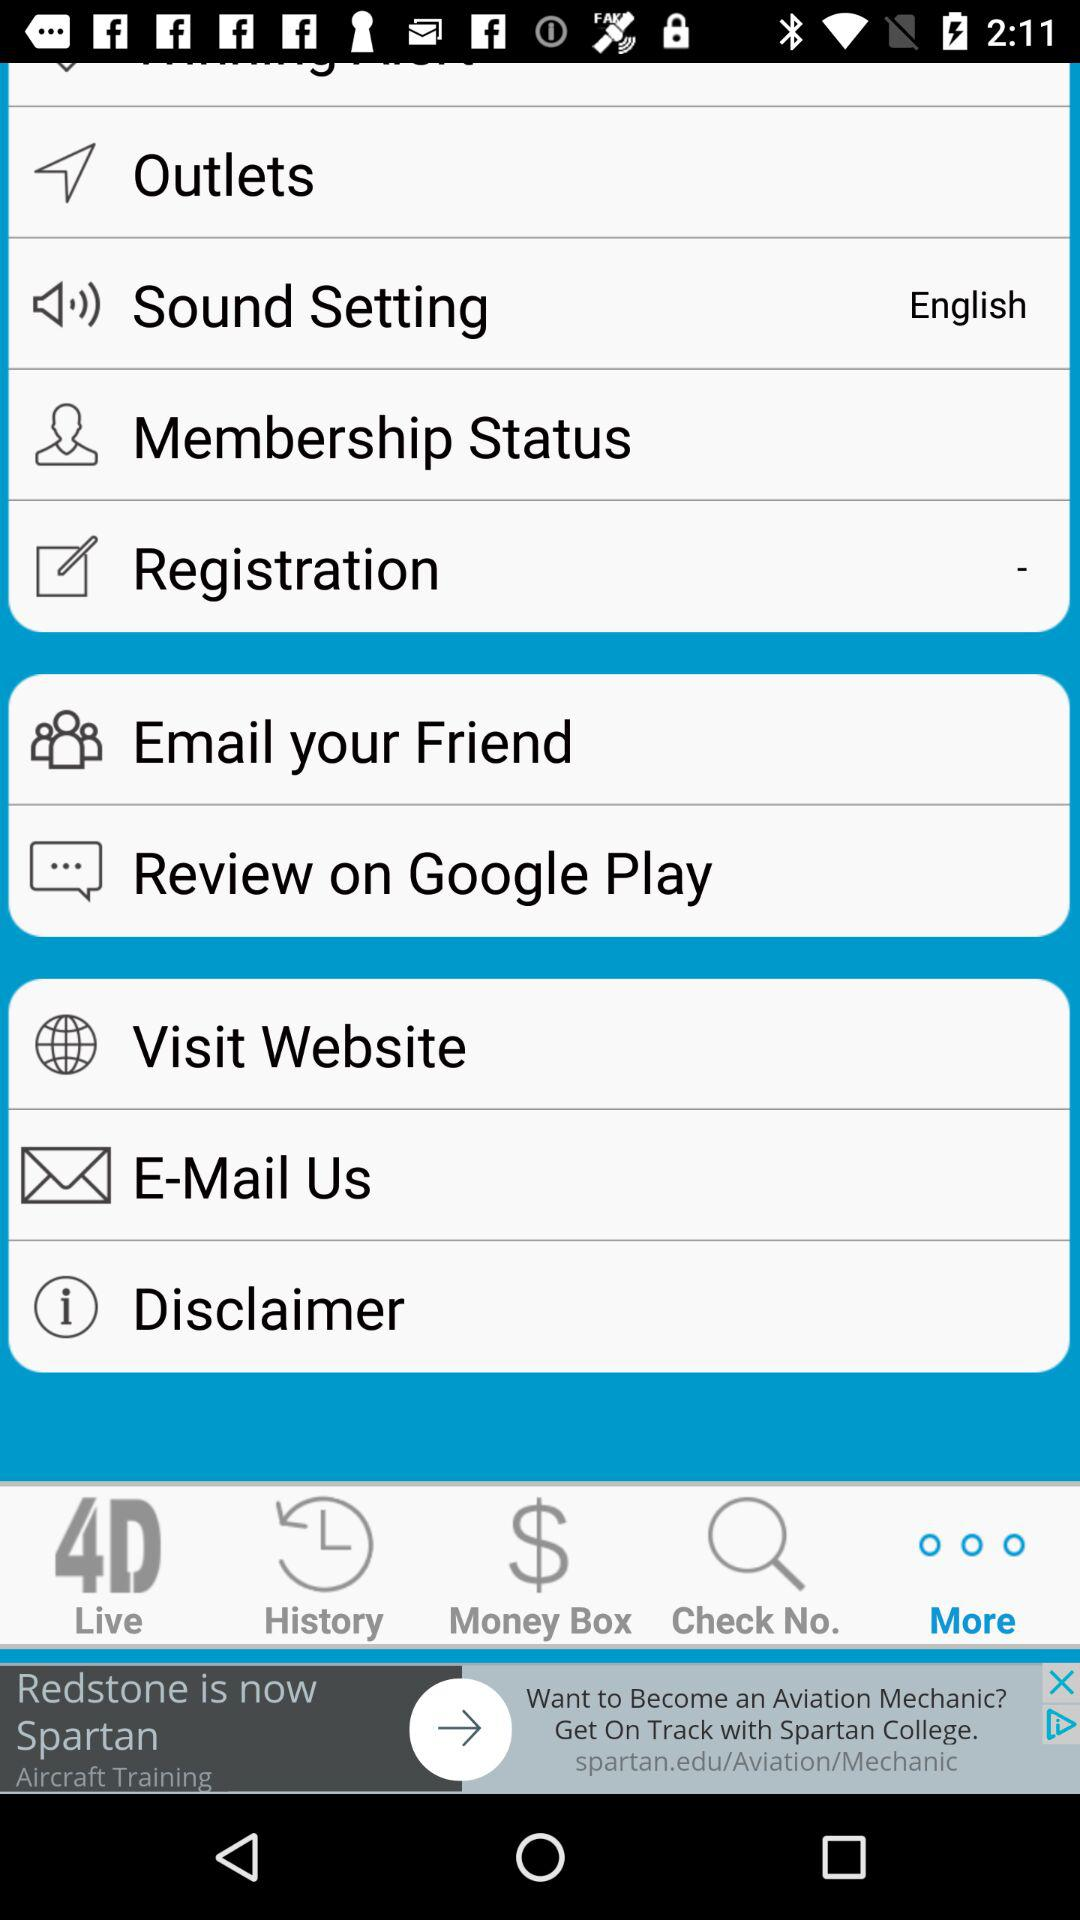Which tab is selected? The selected tab is "More". 